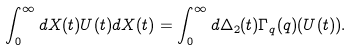<formula> <loc_0><loc_0><loc_500><loc_500>\int _ { 0 } ^ { \infty } d X ( t ) U ( t ) d X ( t ) = \int _ { 0 } ^ { \infty } d \Delta _ { 2 } ( t ) \Gamma _ { q } ( q ) ( U ( t ) ) .</formula> 